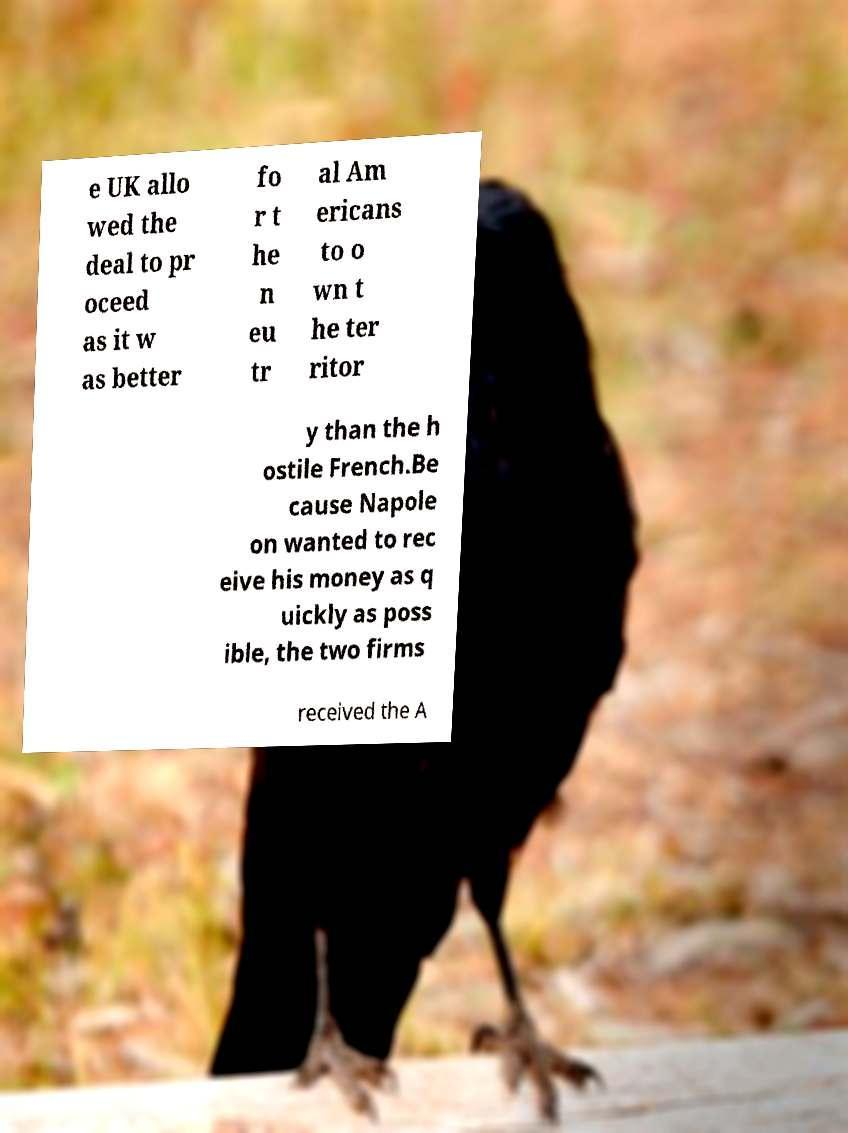There's text embedded in this image that I need extracted. Can you transcribe it verbatim? e UK allo wed the deal to pr oceed as it w as better fo r t he n eu tr al Am ericans to o wn t he ter ritor y than the h ostile French.Be cause Napole on wanted to rec eive his money as q uickly as poss ible, the two firms received the A 